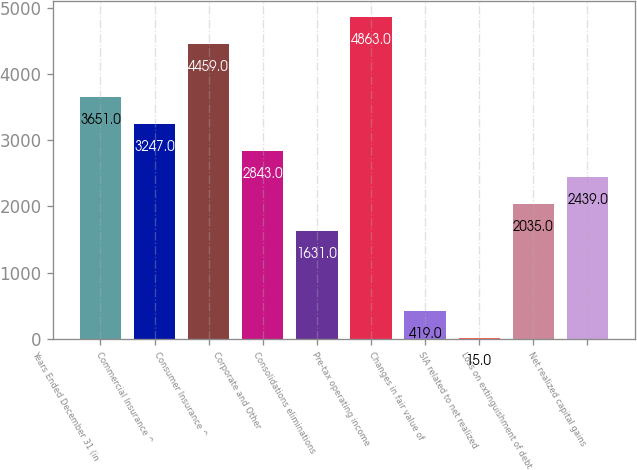<chart> <loc_0><loc_0><loc_500><loc_500><bar_chart><fcel>Years Ended December 31 (in<fcel>Commercial Insurance ^<fcel>Consumer Insurance ^<fcel>Corporate and Other<fcel>Consolidations eliminations<fcel>Pre-tax operating income<fcel>Changes in fair value of<fcel>SIA related to net realized<fcel>Loss on extinguishment of debt<fcel>Net realized capital gains<nl><fcel>3651<fcel>3247<fcel>4459<fcel>2843<fcel>1631<fcel>4863<fcel>419<fcel>15<fcel>2035<fcel>2439<nl></chart> 